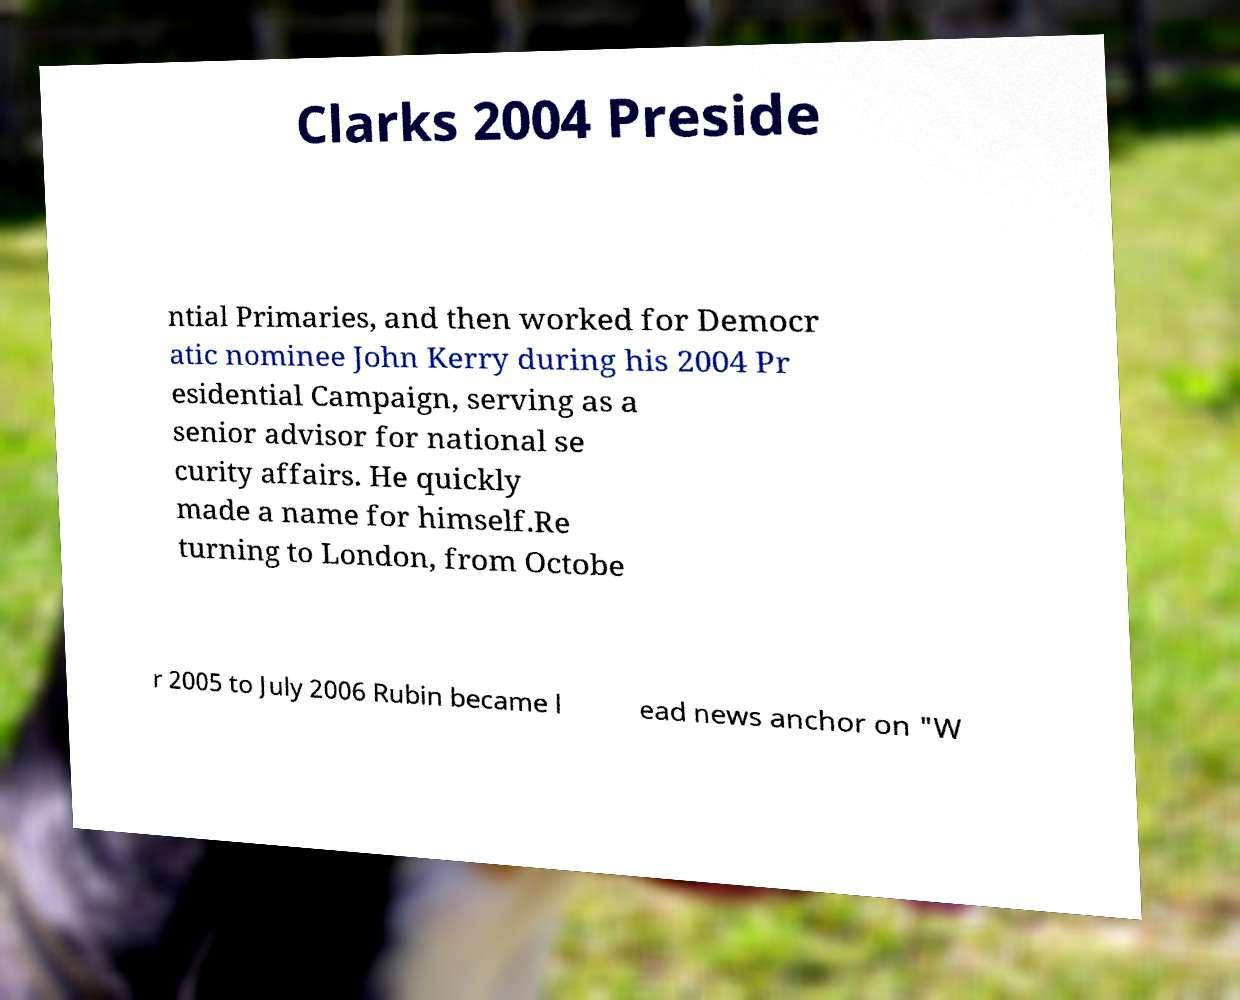Could you extract and type out the text from this image? Clarks 2004 Preside ntial Primaries, and then worked for Democr atic nominee John Kerry during his 2004 Pr esidential Campaign, serving as a senior advisor for national se curity affairs. He quickly made a name for himself.Re turning to London, from Octobe r 2005 to July 2006 Rubin became l ead news anchor on "W 